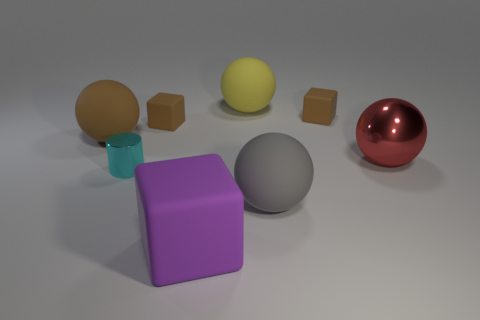Subtract 1 spheres. How many spheres are left? 3 Subtract all brown balls. How many balls are left? 3 Add 1 small matte objects. How many objects exist? 9 Subtract all green spheres. Subtract all cyan blocks. How many spheres are left? 4 Subtract all blocks. How many objects are left? 5 Subtract all large yellow things. Subtract all small brown cubes. How many objects are left? 5 Add 8 cyan cylinders. How many cyan cylinders are left? 9 Add 6 purple metallic balls. How many purple metallic balls exist? 6 Subtract 0 yellow cubes. How many objects are left? 8 